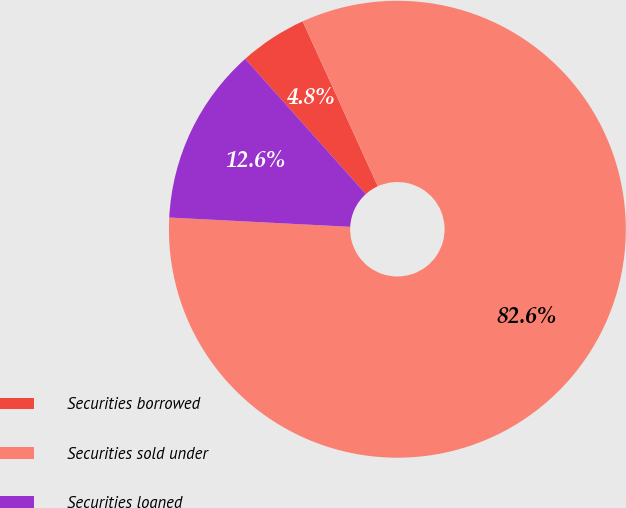Convert chart to OTSL. <chart><loc_0><loc_0><loc_500><loc_500><pie_chart><fcel>Securities borrowed<fcel>Securities sold under<fcel>Securities loaned<nl><fcel>4.8%<fcel>82.62%<fcel>12.58%<nl></chart> 